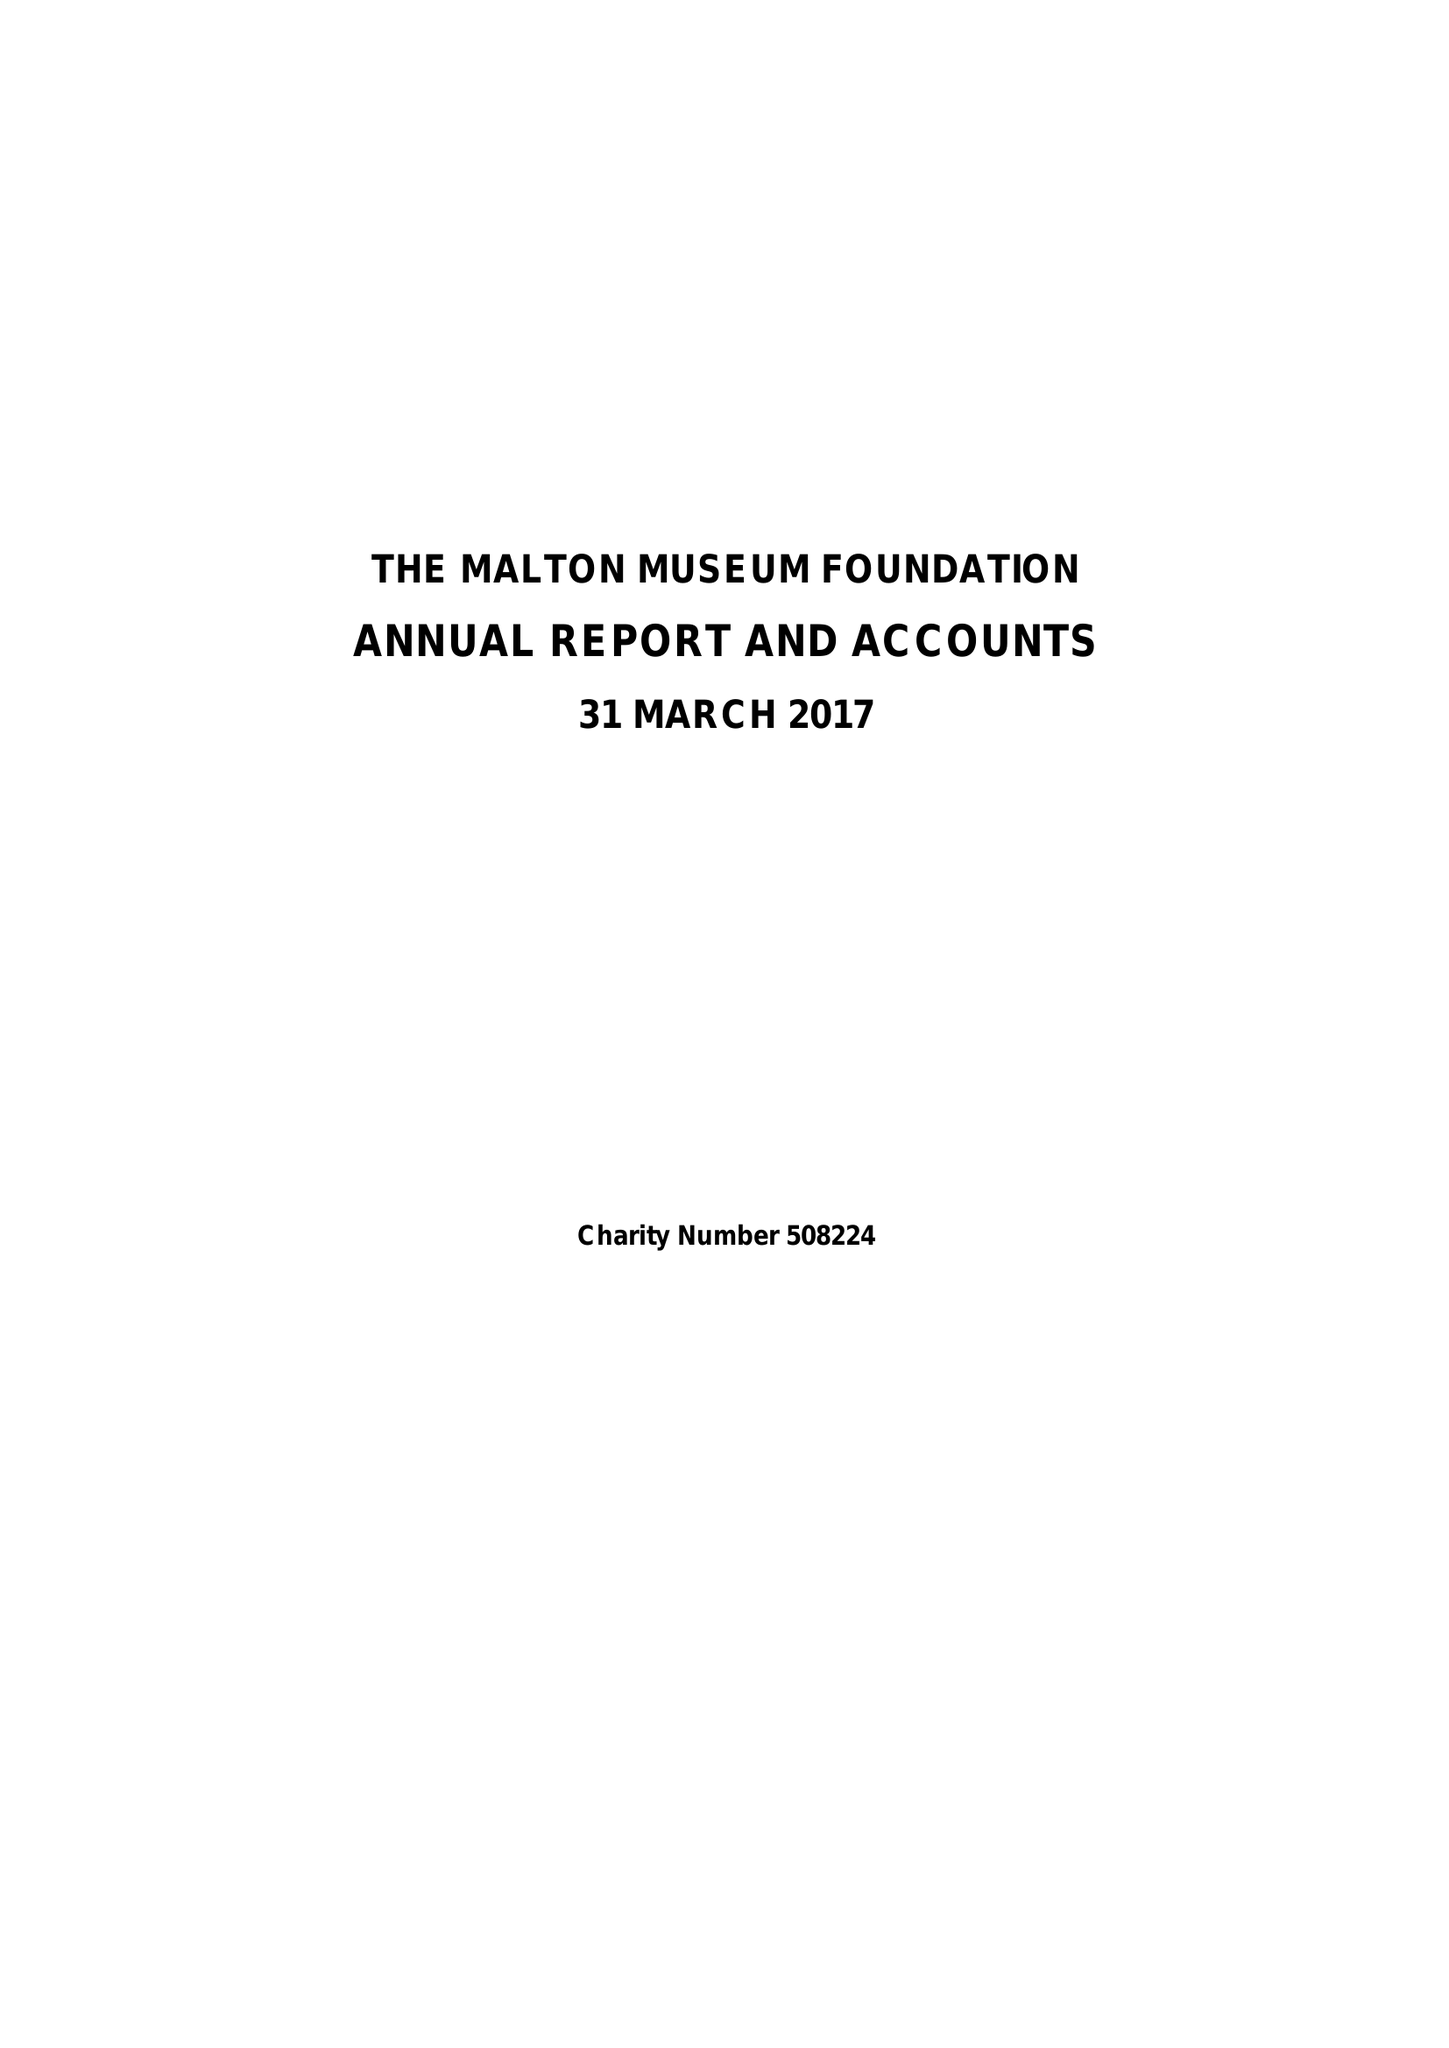What is the value for the spending_annually_in_british_pounds?
Answer the question using a single word or phrase. 93635.00 